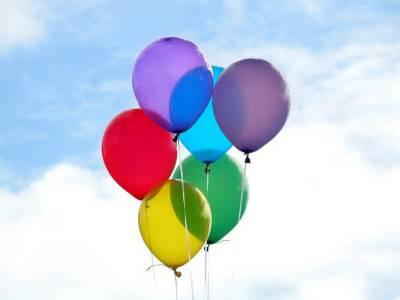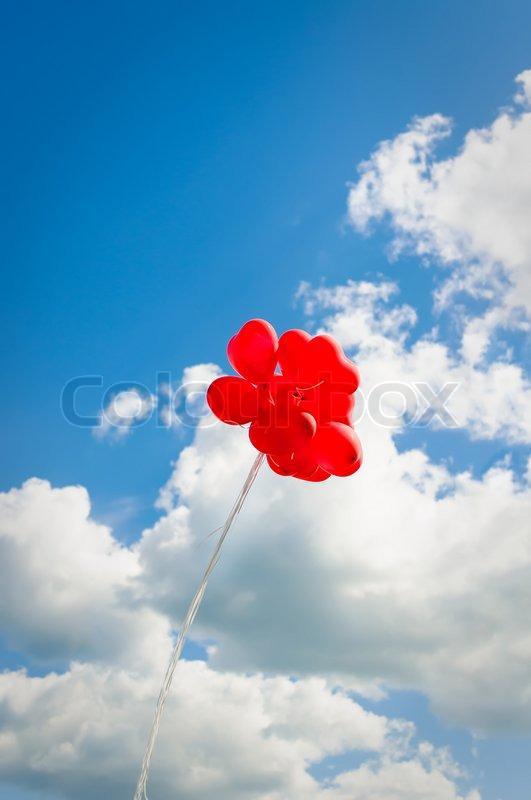The first image is the image on the left, the second image is the image on the right. For the images shown, is this caption "The right image has no more than 2 balloons." true? Answer yes or no. No. The first image is the image on the left, the second image is the image on the right. For the images displayed, is the sentence "There are no more than two balloons in the sky in the image on the right." factually correct? Answer yes or no. No. 